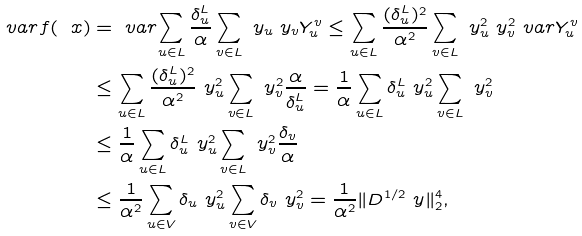<formula> <loc_0><loc_0><loc_500><loc_500>\ v a r { f ( \ x ) } & = \ v a r { \sum _ { u \in L } \frac { \delta _ { u } ^ { L } } { \alpha } \sum _ { v \in L } \ y _ { u } \ y _ { v } Y _ { u } ^ { v } } \leq \sum _ { u \in L } \frac { ( \delta _ { u } ^ { L } ) ^ { 2 } } { \alpha ^ { 2 } } \sum _ { v \in L } \ y _ { u } ^ { 2 } \ y _ { v } ^ { 2 } \ v a r { Y _ { u } ^ { v } } \\ & \leq \sum _ { u \in L } \frac { ( \delta _ { u } ^ { L } ) ^ { 2 } } { \alpha ^ { 2 } } \ y _ { u } ^ { 2 } \sum _ { v \in L } \ y _ { v } ^ { 2 } \frac { \alpha } { \delta _ { u } ^ { L } } = \frac { 1 } { \alpha } \sum _ { u \in L } \delta _ { u } ^ { L } \ y _ { u } ^ { 2 } \sum _ { v \in L } \ y _ { v } ^ { 2 } \\ & \leq \frac { 1 } { \alpha } \sum _ { u \in L } \delta _ { u } ^ { L } \ y _ { u } ^ { 2 } \sum _ { v \in L } \ y _ { v } ^ { 2 } \frac { \delta _ { v } } { \alpha } \\ & \leq \frac { 1 } { \alpha ^ { 2 } } \sum _ { u \in V } \delta _ { u } \ y _ { u } ^ { 2 } \sum _ { v \in V } \delta _ { v } \ y _ { v } ^ { 2 } = \frac { 1 } { \alpha ^ { 2 } } \| D ^ { 1 / 2 } \ y \| _ { 2 } ^ { 4 } ,</formula> 